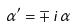<formula> <loc_0><loc_0><loc_500><loc_500>\alpha ^ { \prime } = \mp \, i \, \alpha</formula> 